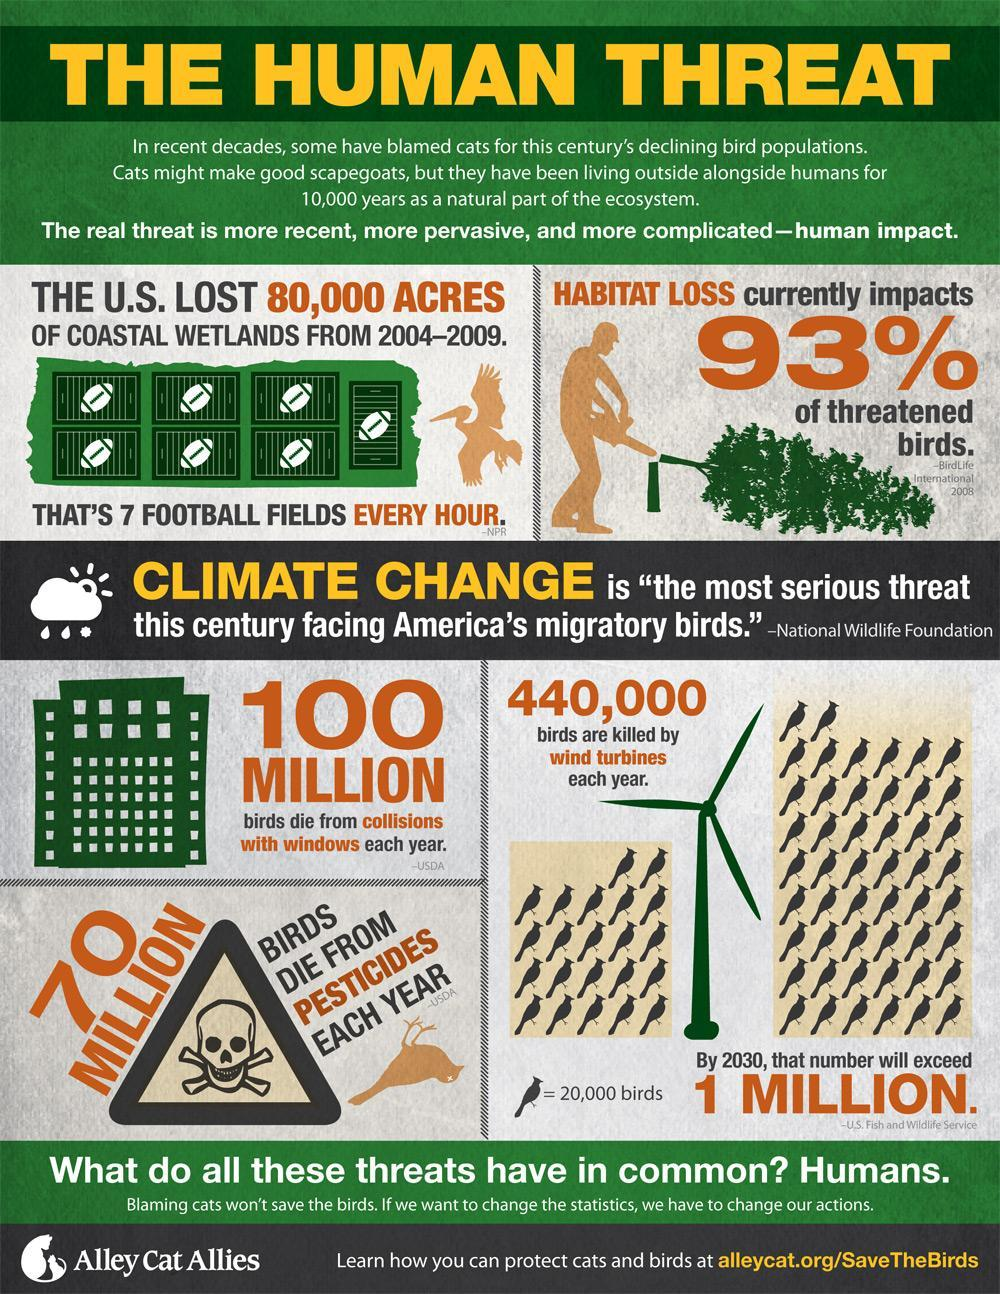What is the expected rise in bird deaths due to turbines in 2030 from the current figure?
Answer the question with a short phrase. 560,000 